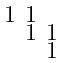<formula> <loc_0><loc_0><loc_500><loc_500>\begin{smallmatrix} 1 & 1 & \\ & 1 & 1 \\ & & 1 \end{smallmatrix}</formula> 